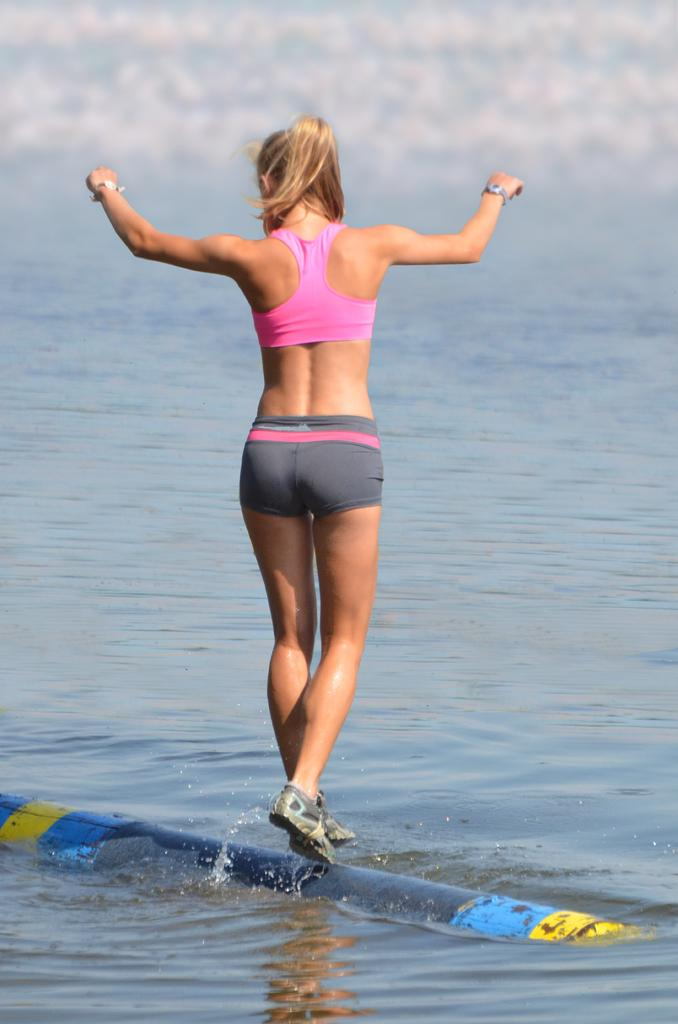What is the main subject of the image? The main subject of the image is a woman. What is the woman doing in the image? The woman is standing on a pole. Where is the pole located? The pole is placed in the water. What type of necklace is the woman wearing in the image? There is no necklace visible in the image. What part of the woman's body can be seen touching the roof in the image? There is no roof present in the image, and therefore no part of the woman's body can be seen touching a roof. 